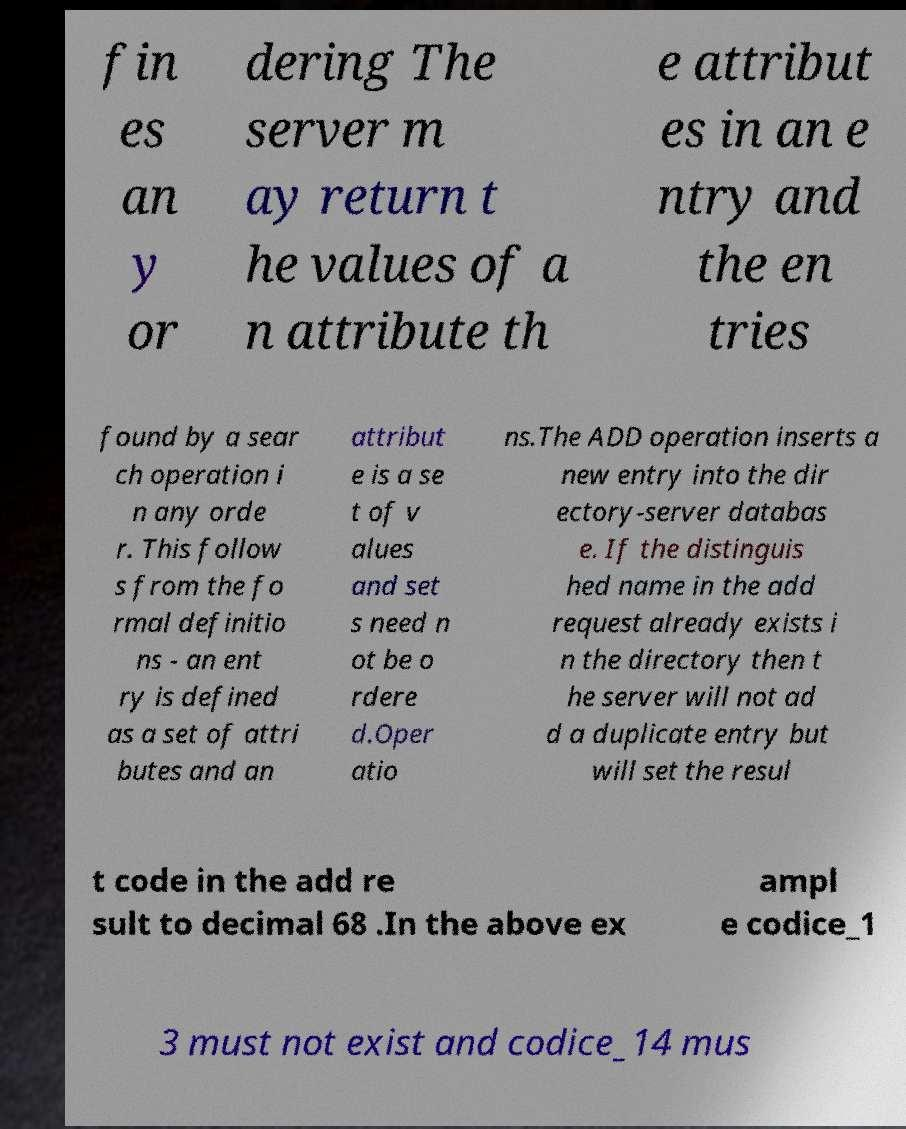Can you accurately transcribe the text from the provided image for me? fin es an y or dering The server m ay return t he values of a n attribute th e attribut es in an e ntry and the en tries found by a sear ch operation i n any orde r. This follow s from the fo rmal definitio ns - an ent ry is defined as a set of attri butes and an attribut e is a se t of v alues and set s need n ot be o rdere d.Oper atio ns.The ADD operation inserts a new entry into the dir ectory-server databas e. If the distinguis hed name in the add request already exists i n the directory then t he server will not ad d a duplicate entry but will set the resul t code in the add re sult to decimal 68 .In the above ex ampl e codice_1 3 must not exist and codice_14 mus 